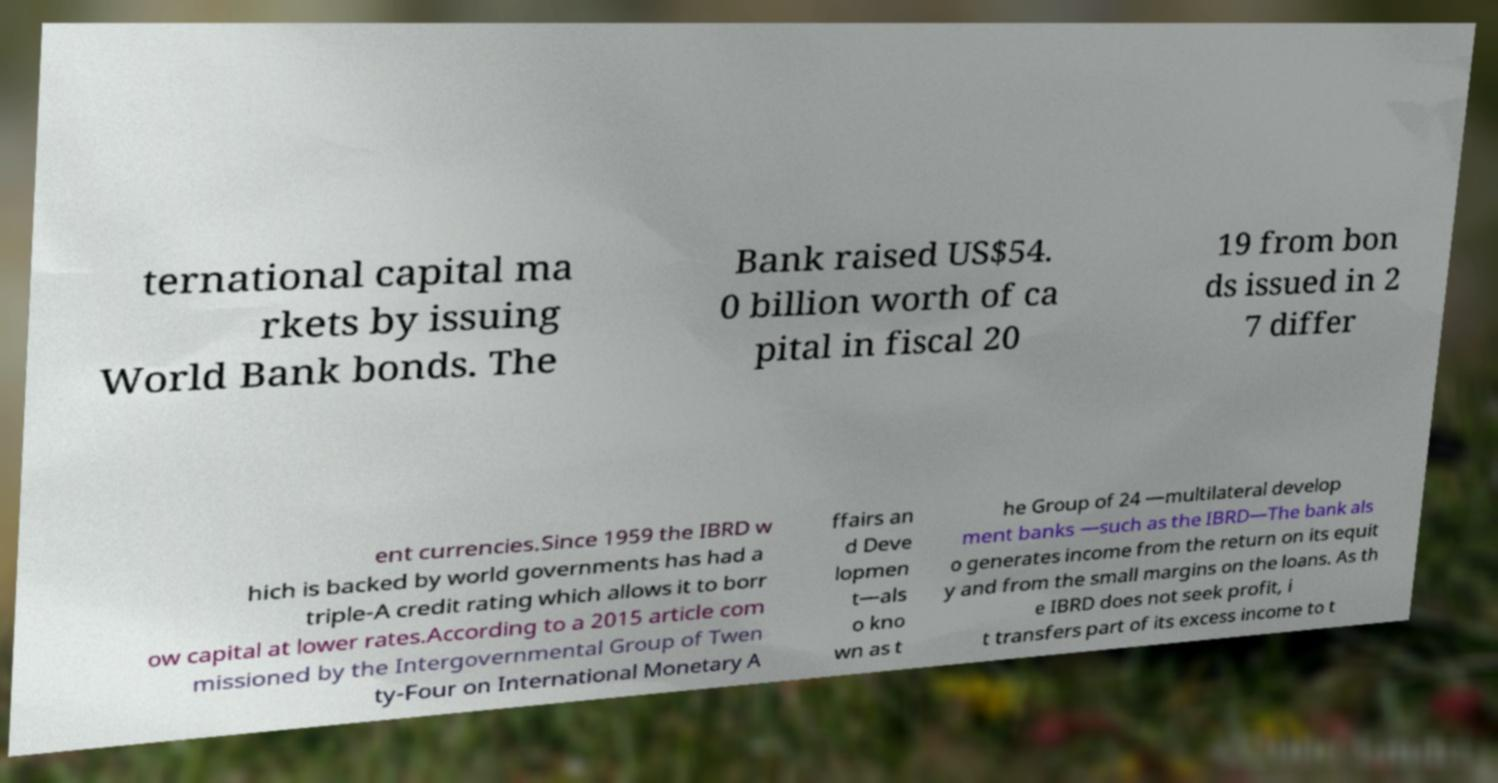Please identify and transcribe the text found in this image. ternational capital ma rkets by issuing World Bank bonds. The Bank raised US$54. 0 billion worth of ca pital in fiscal 20 19 from bon ds issued in 2 7 differ ent currencies.Since 1959 the IBRD w hich is backed by world governments has had a triple-A credit rating which allows it to borr ow capital at lower rates.According to a 2015 article com missioned by the Intergovernmental Group of Twen ty-Four on International Monetary A ffairs an d Deve lopmen t—als o kno wn as t he Group of 24 —multilateral develop ment banks —such as the IBRD—The bank als o generates income from the return on its equit y and from the small margins on the loans. As th e IBRD does not seek profit, i t transfers part of its excess income to t 